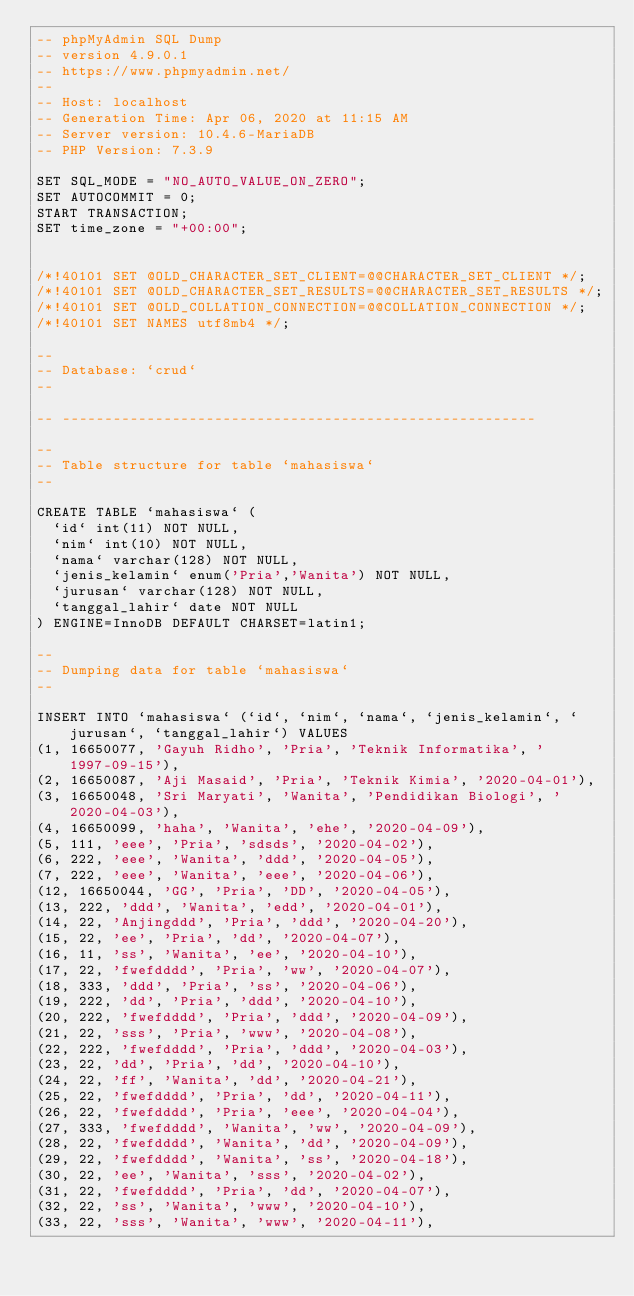<code> <loc_0><loc_0><loc_500><loc_500><_SQL_>-- phpMyAdmin SQL Dump
-- version 4.9.0.1
-- https://www.phpmyadmin.net/
--
-- Host: localhost
-- Generation Time: Apr 06, 2020 at 11:15 AM
-- Server version: 10.4.6-MariaDB
-- PHP Version: 7.3.9

SET SQL_MODE = "NO_AUTO_VALUE_ON_ZERO";
SET AUTOCOMMIT = 0;
START TRANSACTION;
SET time_zone = "+00:00";


/*!40101 SET @OLD_CHARACTER_SET_CLIENT=@@CHARACTER_SET_CLIENT */;
/*!40101 SET @OLD_CHARACTER_SET_RESULTS=@@CHARACTER_SET_RESULTS */;
/*!40101 SET @OLD_COLLATION_CONNECTION=@@COLLATION_CONNECTION */;
/*!40101 SET NAMES utf8mb4 */;

--
-- Database: `crud`
--

-- --------------------------------------------------------

--
-- Table structure for table `mahasiswa`
--

CREATE TABLE `mahasiswa` (
  `id` int(11) NOT NULL,
  `nim` int(10) NOT NULL,
  `nama` varchar(128) NOT NULL,
  `jenis_kelamin` enum('Pria','Wanita') NOT NULL,
  `jurusan` varchar(128) NOT NULL,
  `tanggal_lahir` date NOT NULL
) ENGINE=InnoDB DEFAULT CHARSET=latin1;

--
-- Dumping data for table `mahasiswa`
--

INSERT INTO `mahasiswa` (`id`, `nim`, `nama`, `jenis_kelamin`, `jurusan`, `tanggal_lahir`) VALUES
(1, 16650077, 'Gayuh Ridho', 'Pria', 'Teknik Informatika', '1997-09-15'),
(2, 16650087, 'Aji Masaid', 'Pria', 'Teknik Kimia', '2020-04-01'),
(3, 16650048, 'Sri Maryati', 'Wanita', 'Pendidikan Biologi', '2020-04-03'),
(4, 16650099, 'haha', 'Wanita', 'ehe', '2020-04-09'),
(5, 111, 'eee', 'Pria', 'sdsds', '2020-04-02'),
(6, 222, 'eee', 'Wanita', 'ddd', '2020-04-05'),
(7, 222, 'eee', 'Wanita', 'eee', '2020-04-06'),
(12, 16650044, 'GG', 'Pria', 'DD', '2020-04-05'),
(13, 222, 'ddd', 'Wanita', 'edd', '2020-04-01'),
(14, 22, 'Anjingddd', 'Pria', 'ddd', '2020-04-20'),
(15, 22, 'ee', 'Pria', 'dd', '2020-04-07'),
(16, 11, 'ss', 'Wanita', 'ee', '2020-04-10'),
(17, 22, 'fwefdddd', 'Pria', 'ww', '2020-04-07'),
(18, 333, 'ddd', 'Pria', 'ss', '2020-04-06'),
(19, 222, 'dd', 'Pria', 'ddd', '2020-04-10'),
(20, 222, 'fwefdddd', 'Pria', 'ddd', '2020-04-09'),
(21, 22, 'sss', 'Pria', 'www', '2020-04-08'),
(22, 222, 'fwefdddd', 'Pria', 'ddd', '2020-04-03'),
(23, 22, 'dd', 'Pria', 'dd', '2020-04-10'),
(24, 22, 'ff', 'Wanita', 'dd', '2020-04-21'),
(25, 22, 'fwefdddd', 'Pria', 'dd', '2020-04-11'),
(26, 22, 'fwefdddd', 'Pria', 'eee', '2020-04-04'),
(27, 333, 'fwefdddd', 'Wanita', 'ww', '2020-04-09'),
(28, 22, 'fwefdddd', 'Wanita', 'dd', '2020-04-09'),
(29, 22, 'fwefdddd', 'Wanita', 'ss', '2020-04-18'),
(30, 22, 'ee', 'Wanita', 'sss', '2020-04-02'),
(31, 22, 'fwefdddd', 'Pria', 'dd', '2020-04-07'),
(32, 22, 'ss', 'Wanita', 'www', '2020-04-10'),
(33, 22, 'sss', 'Wanita', 'www', '2020-04-11'),</code> 